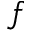<formula> <loc_0><loc_0><loc_500><loc_500>f</formula> 